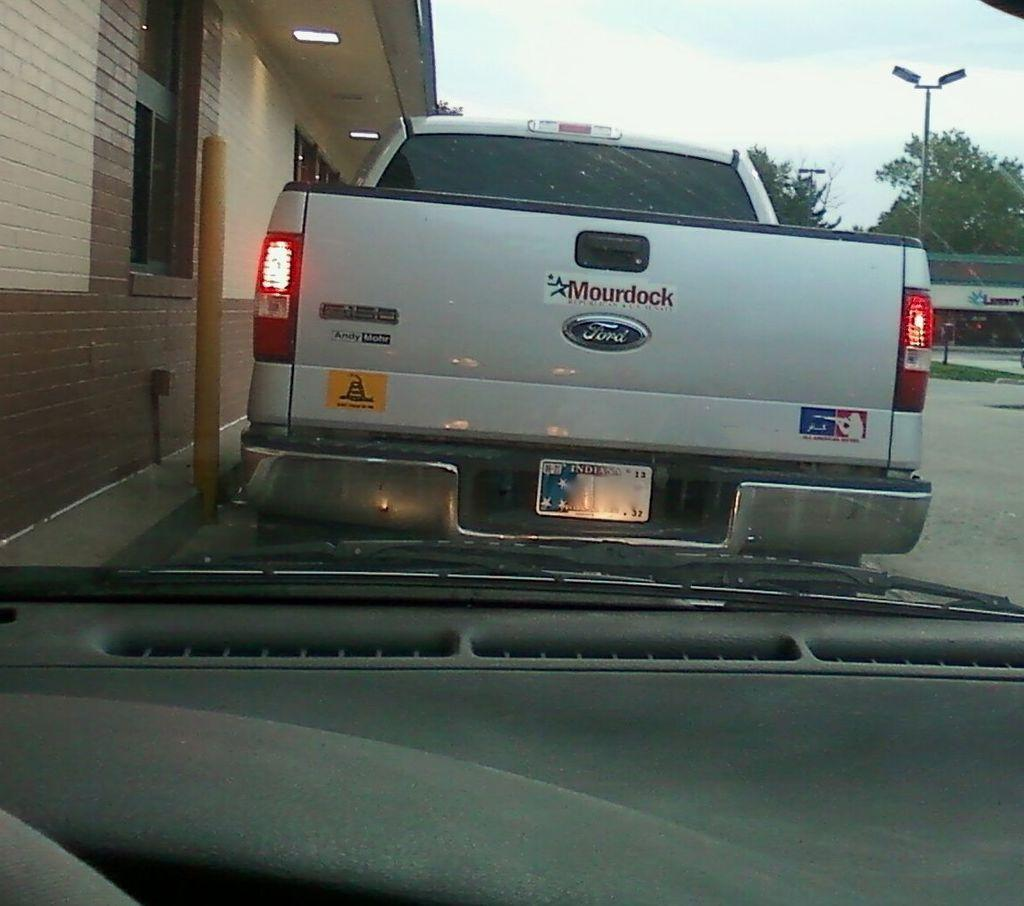<image>
Provide a brief description of the given image. A Ford pickup that says Mourdock on the tailgate. 